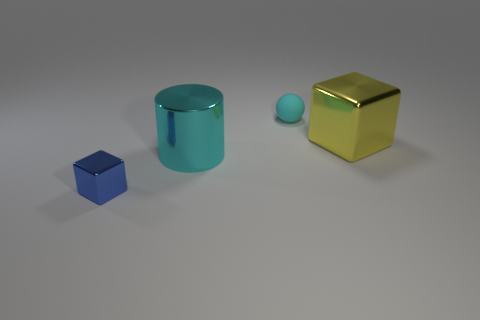Add 4 tiny purple metal balls. How many objects exist? 8 Subtract all yellow cubes. How many cubes are left? 1 Subtract 0 green balls. How many objects are left? 4 Subtract all cylinders. How many objects are left? 3 Subtract 2 blocks. How many blocks are left? 0 Subtract all gray blocks. Subtract all blue cylinders. How many blocks are left? 2 Subtract all blue cylinders. How many brown blocks are left? 0 Subtract all small red spheres. Subtract all cyan cylinders. How many objects are left? 3 Add 3 large yellow things. How many large yellow things are left? 4 Add 4 large purple things. How many large purple things exist? 4 